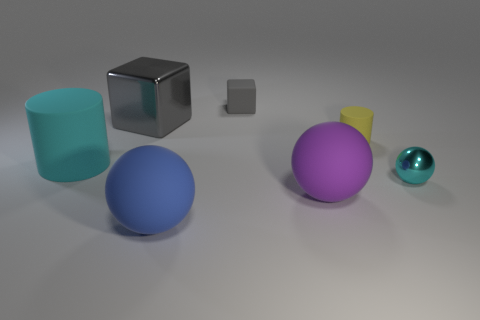Add 3 big cylinders. How many objects exist? 10 Subtract all blocks. How many objects are left? 5 Subtract all shiny spheres. Subtract all cyan spheres. How many objects are left? 5 Add 5 tiny yellow things. How many tiny yellow things are left? 6 Add 6 green metal blocks. How many green metal blocks exist? 6 Subtract 0 cyan blocks. How many objects are left? 7 